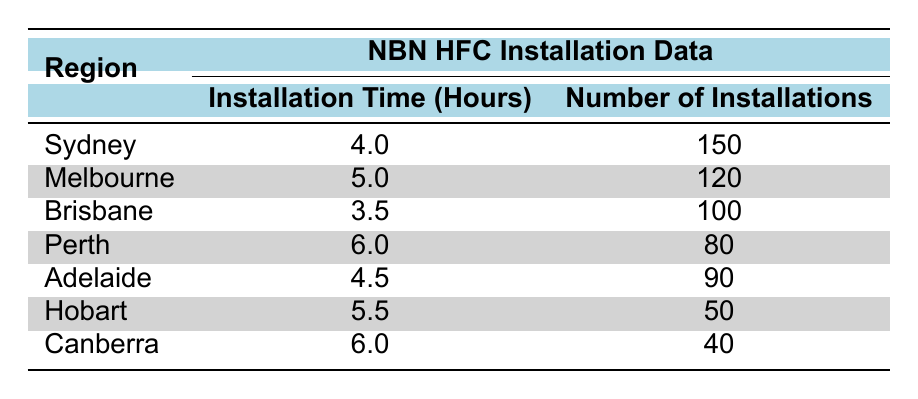What is the installation time for Sydney? The table shows that the installation time for Sydney is 4.0 hours.
Answer: 4.0 hours Which region has the longest installation time? By looking at the installation time column, Perth and Canberra both have the longest installation time of 6.0 hours.
Answer: Perth and Canberra How many installations were conducted in Melbourne? The table states that the number of installations for Melbourne is 120.
Answer: 120 What is the average installation time across all regions? To find the average, sum the installation times (4 + 5 + 3.5 + 6 + 4.5 + 5.5 + 6) = 34.5 hours for 7 regions. Thus, average = 34.5/7 = 4.93 hours.
Answer: 4.93 hours Is Brisbane's installation time less than the average installation time? The average installation time is 4.93 hours, and Brisbane's installation time is 3.5 hours, which is indeed less than the average.
Answer: Yes Which region has the least number of installations? By comparing the number of installations, Hobart has the least with 50 installations.
Answer: Hobart What is the difference in installation time between the region with the highest and lowest installation time? The highest installation time is 6.0 hours (Perth and Canberra) and the lowest is 3.5 hours (Brisbane). The difference is 6 - 3.5 = 2.5 hours.
Answer: 2.5 hours How many total installations are there across all regions? Adding up the number of installations (150 + 120 + 100 + 80 + 90 + 50 + 40) = 630 total installations.
Answer: 630 Does any region have a combination of an installation time greater than 5 hours and more than 100 installations? Looking at the table, Melbourne (5.0 hours, 120 installations) and Hobart (5.5 hours, 50 installations) do not fit, but Perth (6.0 hours, 80 installations) and Canberra (6.0 hours, 40 installations) do not meet the installation number, so the answer is no.
Answer: No 